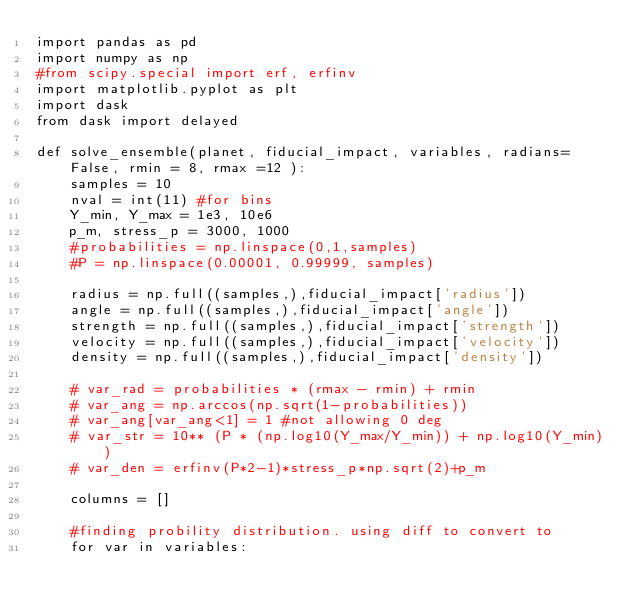<code> <loc_0><loc_0><loc_500><loc_500><_Python_>import pandas as pd
import numpy as np
#from scipy.special import erf, erfinv
import matplotlib.pyplot as plt
import dask
from dask import delayed

def solve_ensemble(planet, fiducial_impact, variables, radians=False, rmin = 8, rmax =12 ):
    samples = 10
    nval = int(11) #for bins
    Y_min, Y_max = 1e3, 10e6
    p_m, stress_p = 3000, 1000
    #probabilities = np.linspace(0,1,samples)
    #P = np.linspace(0.00001, 0.99999, samples)
    
    radius = np.full((samples,),fiducial_impact['radius'])
    angle = np.full((samples,),fiducial_impact['angle'])
    strength = np.full((samples,),fiducial_impact['strength'])
    velocity = np.full((samples,),fiducial_impact['velocity'])
    density = np.full((samples,),fiducial_impact['density'])
    
    # var_rad = probabilities * (rmax - rmin) + rmin
    # var_ang = np.arccos(np.sqrt(1-probabilities))
    # var_ang[var_ang<1] = 1 #not allowing 0 deg 
    # var_str = 10** (P * (np.log10(Y_max/Y_min)) + np.log10(Y_min))
    # var_den = erfinv(P*2-1)*stress_p*np.sqrt(2)+p_m

    columns = []

    #finding probility distribution. using diff to convert to 
    for var in variables:</code> 